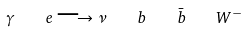<formula> <loc_0><loc_0><loc_500><loc_500>\gamma \quad e \longrightarrow \nu \quad b \quad \bar { b } \quad W ^ { - }</formula> 